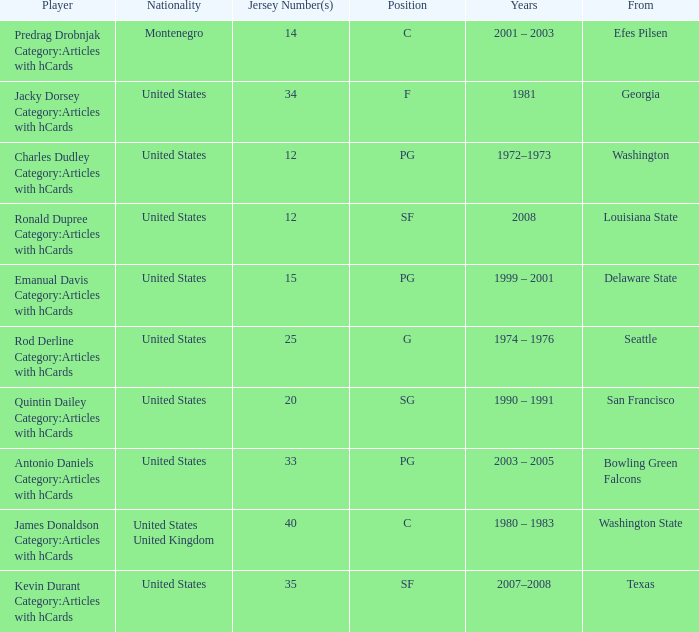During what years did the us athlete with jersey number 25 from delaware state compete? 1999 – 2001. 